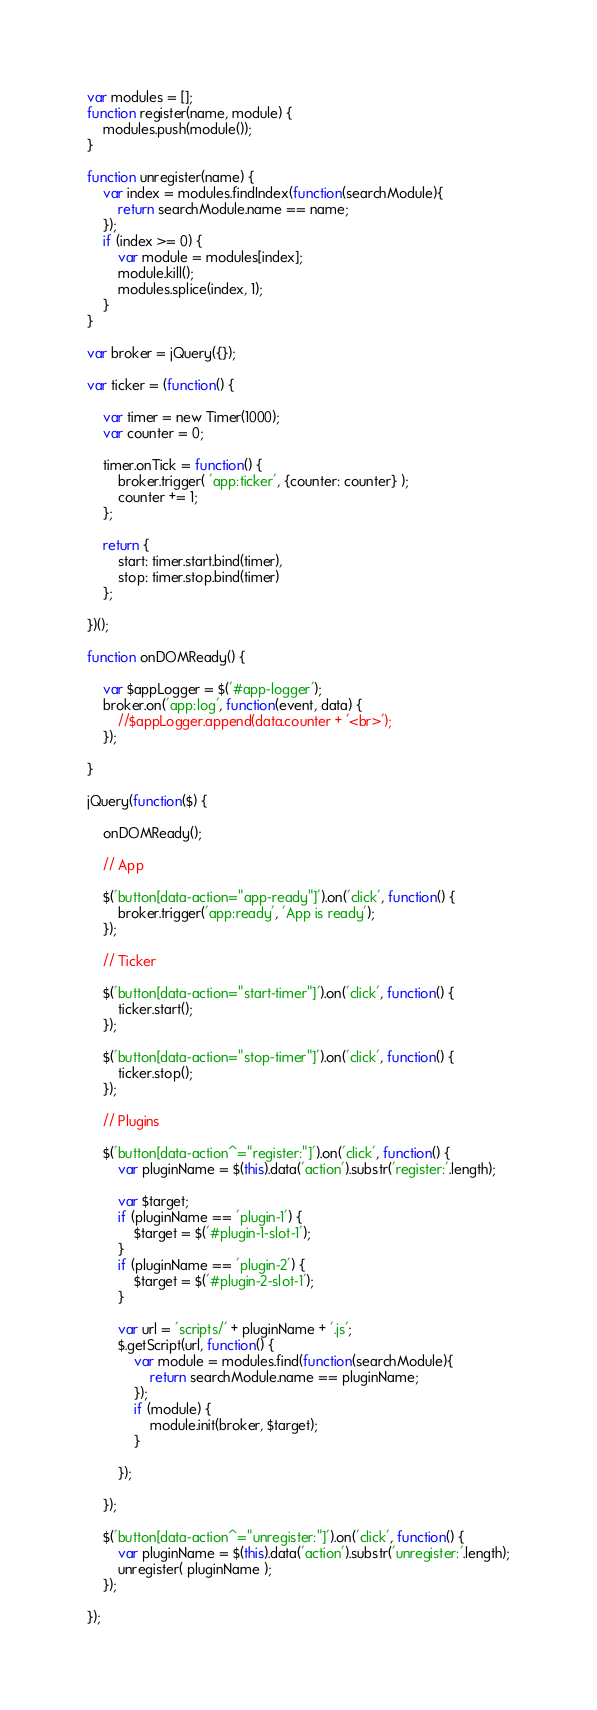Convert code to text. <code><loc_0><loc_0><loc_500><loc_500><_JavaScript_>var modules = [];
function register(name, module) {
	modules.push(module());
}

function unregister(name) {
	var index = modules.findIndex(function(searchModule){
		return searchModule.name == name;
	});
	if (index >= 0) {
		var module = modules[index];
		module.kill();
		modules.splice(index, 1);
	}
}

var broker = jQuery({});

var ticker = (function() {

	var timer = new Timer(1000);
	var counter = 0;

	timer.onTick = function() {
		broker.trigger( 'app:ticker', {counter: counter} );
		counter += 1;
	};
	
	return {
		start: timer.start.bind(timer),
		stop: timer.stop.bind(timer)
	};

})();

function onDOMReady() {

	var $appLogger = $('#app-logger');
	broker.on('app:log', function(event, data) {
		//$appLogger.append(data.counter + '<br>');
	});

}

jQuery(function($) {

	onDOMReady();

	// App
		
	$('button[data-action="app-ready"]').on('click', function() {
		broker.trigger('app:ready', 'App is ready');
	});

	// Ticker
		
	$('button[data-action="start-timer"]').on('click', function() {
		ticker.start();
	});

	$('button[data-action="stop-timer"]').on('click', function() {
		ticker.stop();
	});

	// Plugins
	
	$('button[data-action^="register:"]').on('click', function() {
		var pluginName = $(this).data('action').substr('register:'.length);

		var $target;
		if (pluginName == 'plugin-1') {
			$target = $('#plugin-1-slot-1');
		}
		if (pluginName == 'plugin-2') {
			$target = $('#plugin-2-slot-1');
		}

		var url = 'scripts/' + pluginName + '.js';
		$.getScript(url, function() {
			var module = modules.find(function(searchModule){
				return searchModule.name == pluginName;
			});
			if (module) {
				module.init(broker, $target);
			}
			
		});
		
	});
	
	$('button[data-action^="unregister:"]').on('click', function() {
		var pluginName = $(this).data('action').substr('unregister:'.length);
		unregister( pluginName );
	});

});
</code> 